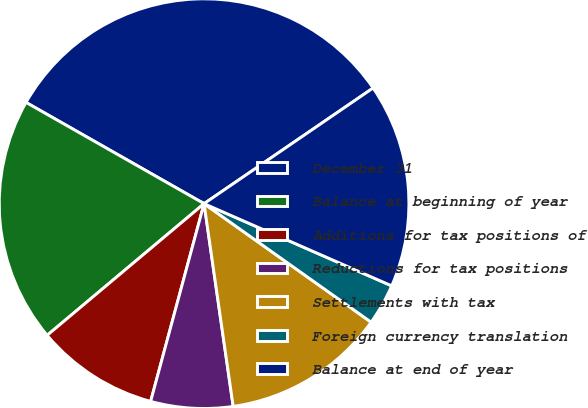<chart> <loc_0><loc_0><loc_500><loc_500><pie_chart><fcel>December 31<fcel>Balance at beginning of year<fcel>Additions for tax positions of<fcel>Reductions for tax positions<fcel>Settlements with tax<fcel>Foreign currency translation<fcel>Balance at end of year<nl><fcel>32.22%<fcel>19.34%<fcel>9.69%<fcel>6.47%<fcel>12.91%<fcel>3.25%<fcel>16.12%<nl></chart> 